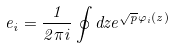Convert formula to latex. <formula><loc_0><loc_0><loc_500><loc_500>e _ { i } = \frac { 1 } { 2 \pi i } \oint d z e ^ { \sqrt { p } \varphi _ { i } ( z ) }</formula> 